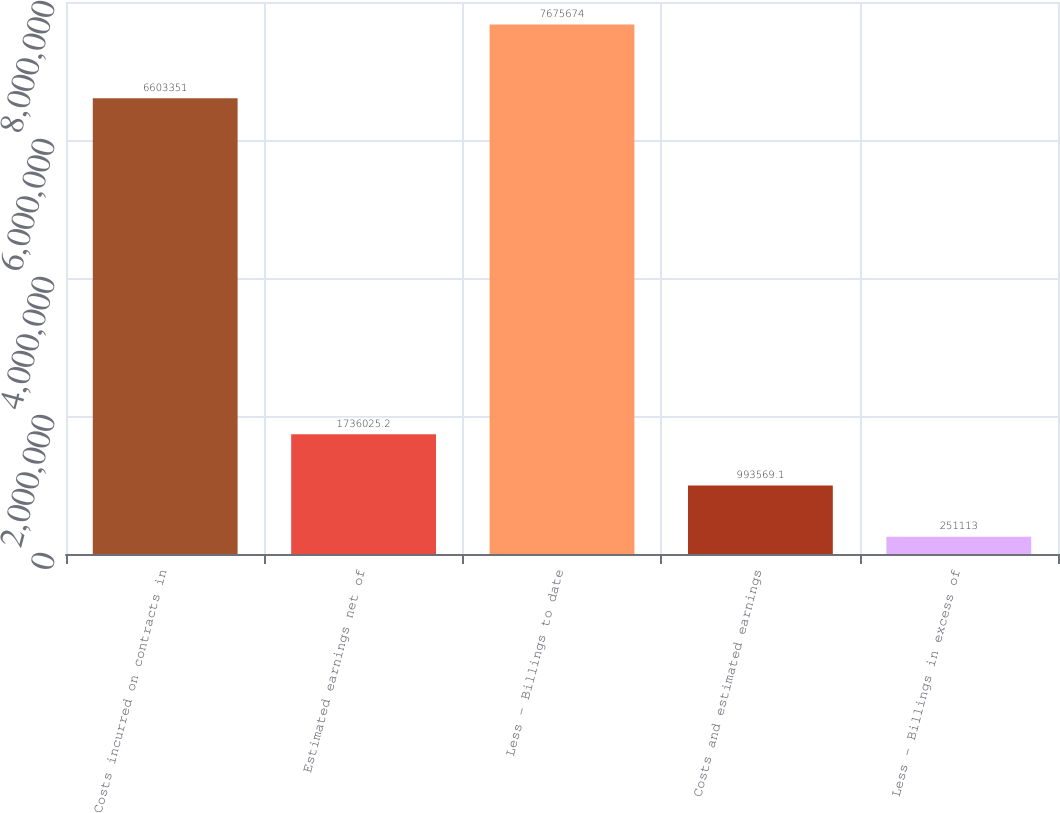<chart> <loc_0><loc_0><loc_500><loc_500><bar_chart><fcel>Costs incurred on contracts in<fcel>Estimated earnings net of<fcel>Less - Billings to date<fcel>Costs and estimated earnings<fcel>Less - Billings in excess of<nl><fcel>6.60335e+06<fcel>1.73603e+06<fcel>7.67567e+06<fcel>993569<fcel>251113<nl></chart> 